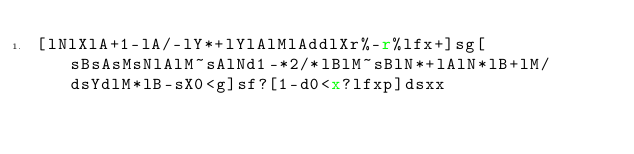Convert code to text. <code><loc_0><loc_0><loc_500><loc_500><_dc_>[lNlXlA+1-lA/-lY*+lYlAlMlAddlXr%-r%lfx+]sg[sBsAsMsNlAlM~sAlNd1-*2/*lBlM~sBlN*+lAlN*lB+lM/dsYdlM*lB-sX0<g]sf?[1-d0<x?lfxp]dsxx</code> 